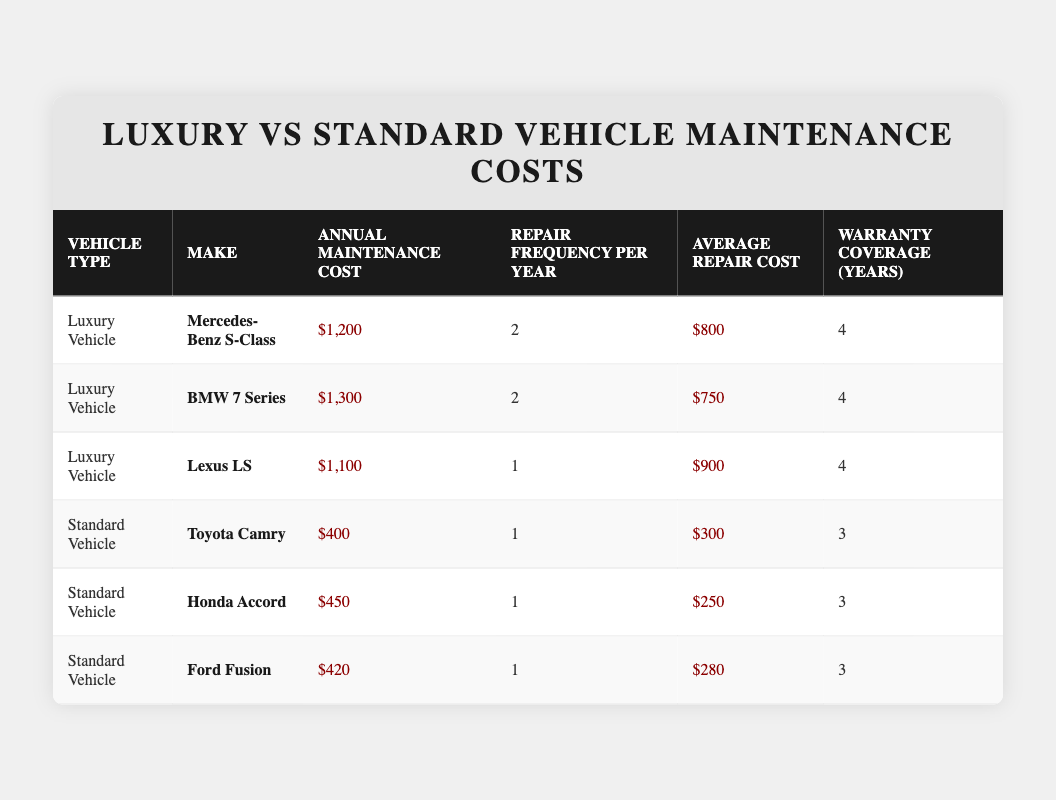What is the annual maintenance cost for the BMW 7 Series? The table directly lists the annual maintenance cost for the BMW 7 Series under the "Annual Maintenance Cost" column. It states that the cost is $1,300.
Answer: $1,300 Which vehicle has the highest annual maintenance cost among luxury vehicles? By comparing the annual maintenance costs for the luxury vehicles listed, the Mercedes-Benz S-Class is $1,200, the BMW 7 Series is $1,300, and the Lexus LS is $1,100. The highest is the BMW 7 Series at $1,300.
Answer: BMW 7 Series What is the difference in average repair cost between the luxury vehicles and the standard vehicles? For luxury vehicles, the average repair costs are $800 (Mercedes-Benz S-Class), $750 (BMW 7 Series), and $900 (Lexus LS). Summing these gives $2,450, and averaging over three vehicles yields $2,450/3 = $816.67. For standard vehicles, the average repair costs are $300 (Toyota Camry), $250 (Honda Accord), and $280 (Ford Fusion), summing to $830 and averaging $830/3 = $276.67. The difference is $816.67 - $276.67 = $540.
Answer: $540 Is it true that the Lexus LS has a lower average repair cost than the Toyota Camry? The average repair cost for the Lexus LS is $900, while for the Toyota Camry, it is $300. Since $900 is greater than $300, the statement is false.
Answer: No What is the total annual maintenance cost for all standard vehicles listed in the table? The annual maintenance costs for the standard vehicles are $400 (Toyota Camry), $450 (Honda Accord), and $420 (Ford Fusion). Summing these values gives $400 + $450 + $420 = $1,270, which is the total annual maintenance cost for all standard vehicles.
Answer: $1,270 Which luxury vehicle has the least repair frequency per year? By reviewing the repair frequencies listed, the Lexus LS has a frequency of 1 repair per year, while the others (Mercedes-Benz S-Class and BMW 7 Series) each have 2. Therefore, the Lexus LS has the least repair frequency.
Answer: Lexus LS 